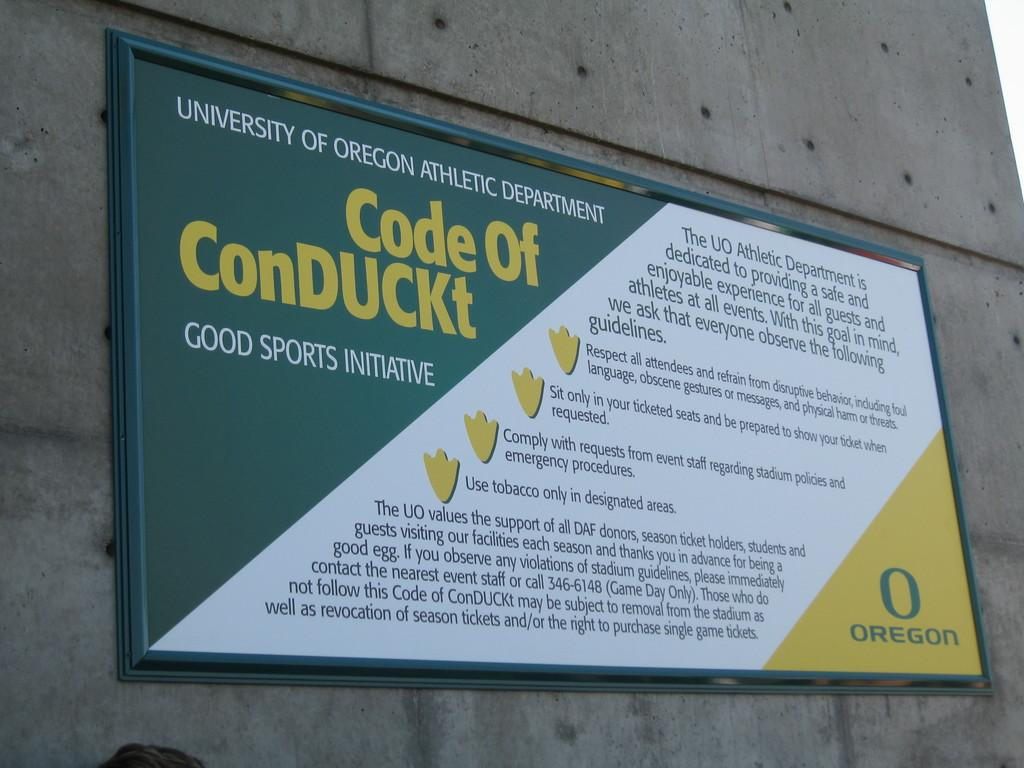<image>
Create a compact narrative representing the image presented. A sign that posts the University of Oregon Code of ConDUCKt. 